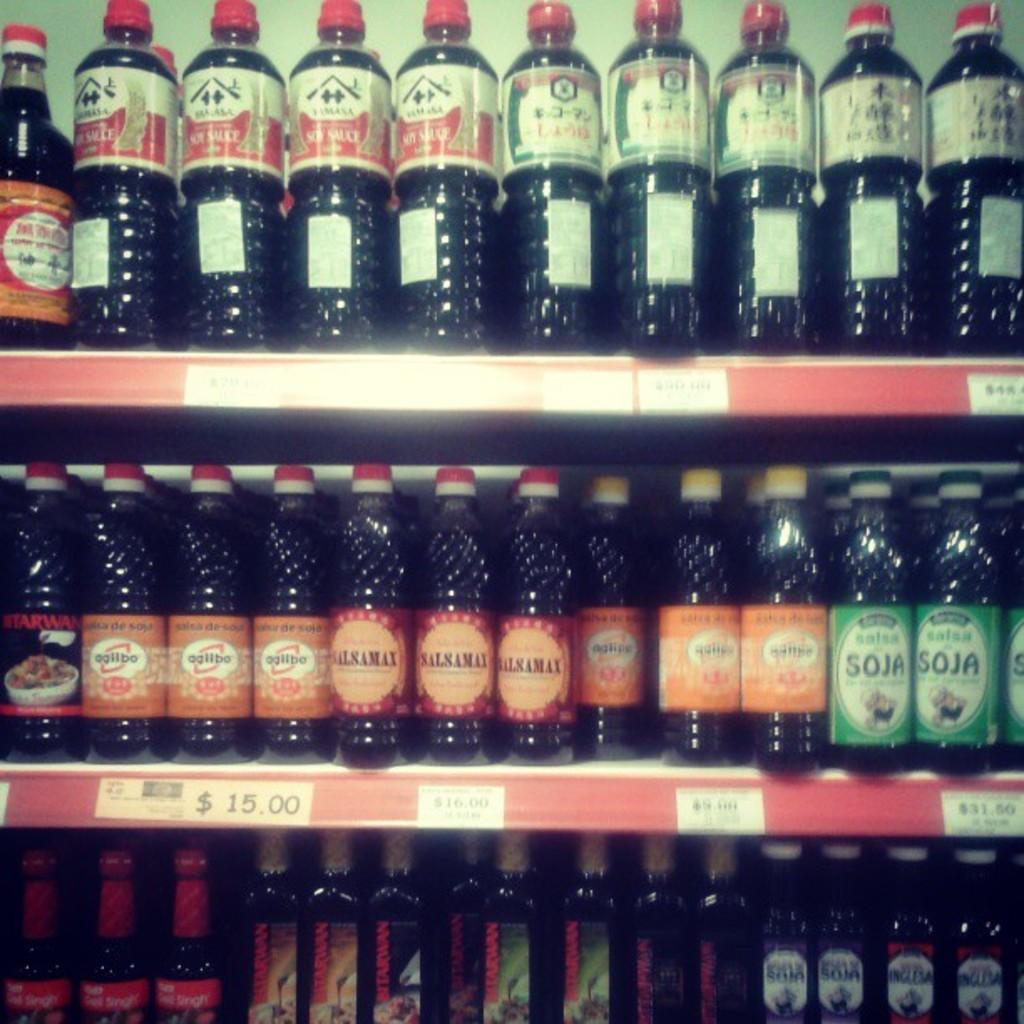What can be seen on the shelves in the image? There are bottles in the shelves in the image. How can the bottles be differentiated from one another? Each bottle has a different color label and different text on its label. What can be observed about the contents of the bottles? The liquid in the bottles is dark in color. What type of fiction is being read by the ducks in the image? There are no ducks present in the image, and therefore no reading activity can be observed. 